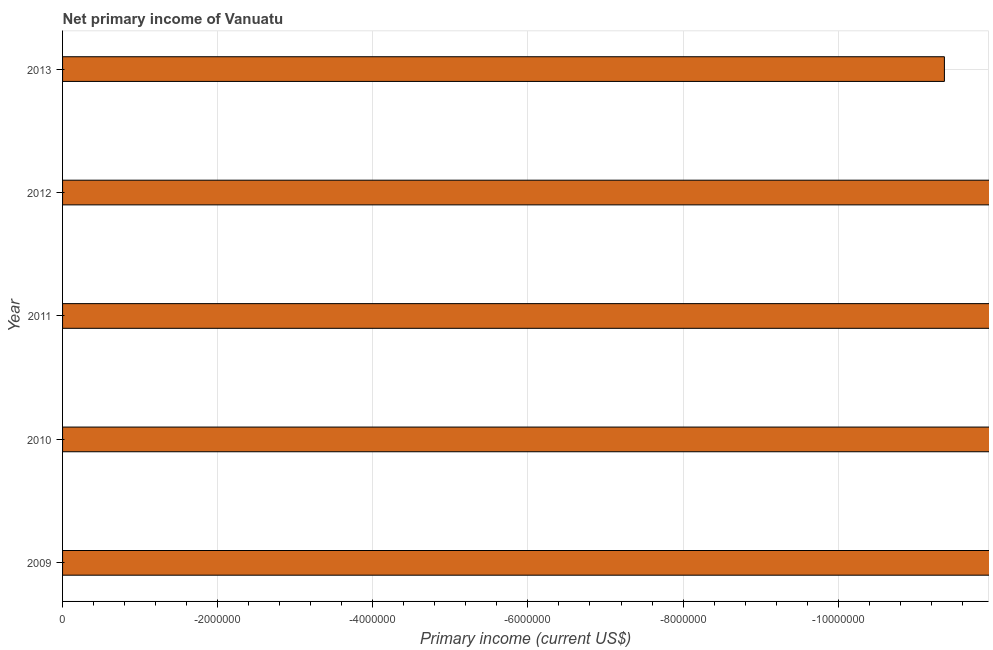Does the graph contain any zero values?
Offer a terse response. Yes. What is the title of the graph?
Make the answer very short. Net primary income of Vanuatu. What is the label or title of the X-axis?
Offer a very short reply. Primary income (current US$). What is the sum of the amount of primary income?
Your response must be concise. 0. What is the median amount of primary income?
Provide a short and direct response. 0. In how many years, is the amount of primary income greater than the average amount of primary income taken over all years?
Provide a short and direct response. 0. How many years are there in the graph?
Give a very brief answer. 5. What is the difference between two consecutive major ticks on the X-axis?
Your answer should be compact. 2.00e+06. What is the Primary income (current US$) of 2009?
Make the answer very short. 0. What is the Primary income (current US$) in 2010?
Ensure brevity in your answer.  0. 